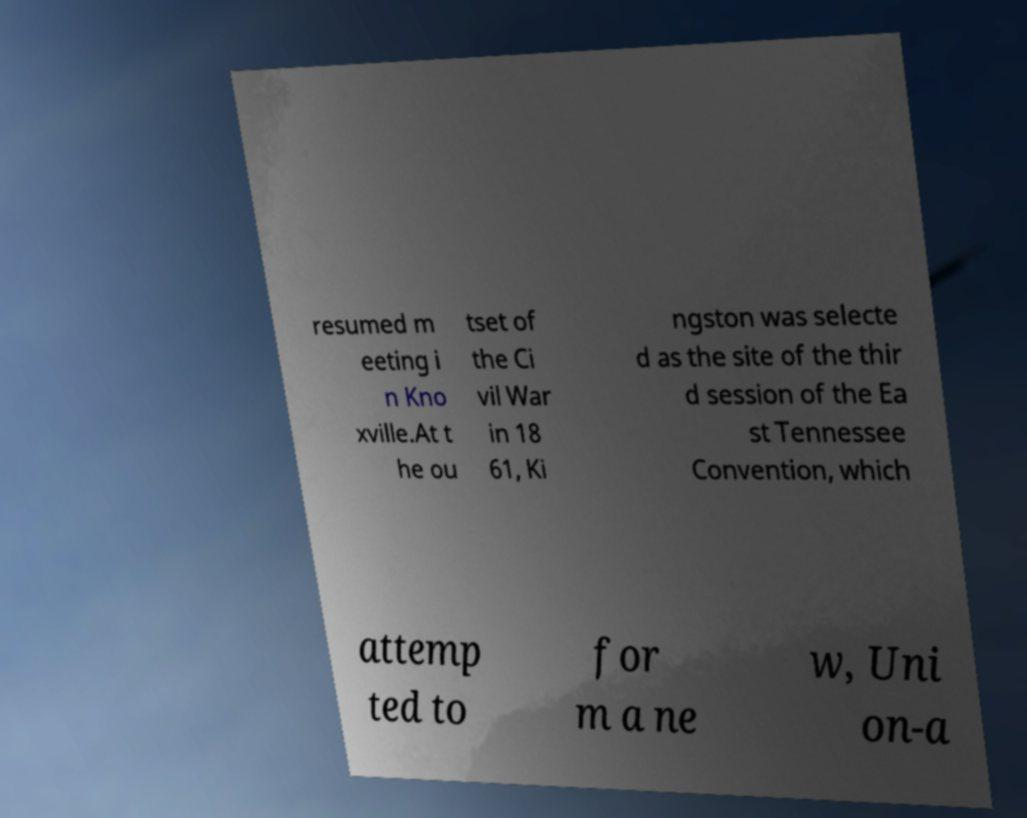I need the written content from this picture converted into text. Can you do that? resumed m eeting i n Kno xville.At t he ou tset of the Ci vil War in 18 61, Ki ngston was selecte d as the site of the thir d session of the Ea st Tennessee Convention, which attemp ted to for m a ne w, Uni on-a 